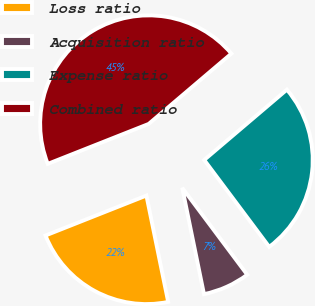Convert chart. <chart><loc_0><loc_0><loc_500><loc_500><pie_chart><fcel>Loss ratio<fcel>Acquisition ratio<fcel>Expense ratio<fcel>Combined ratio<nl><fcel>22.21%<fcel>7.01%<fcel>25.99%<fcel>44.78%<nl></chart> 